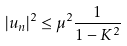<formula> <loc_0><loc_0><loc_500><loc_500>\left | u _ { n } \right | ^ { 2 } \leq \mu ^ { 2 } \frac { 1 } { 1 - K ^ { 2 } }</formula> 